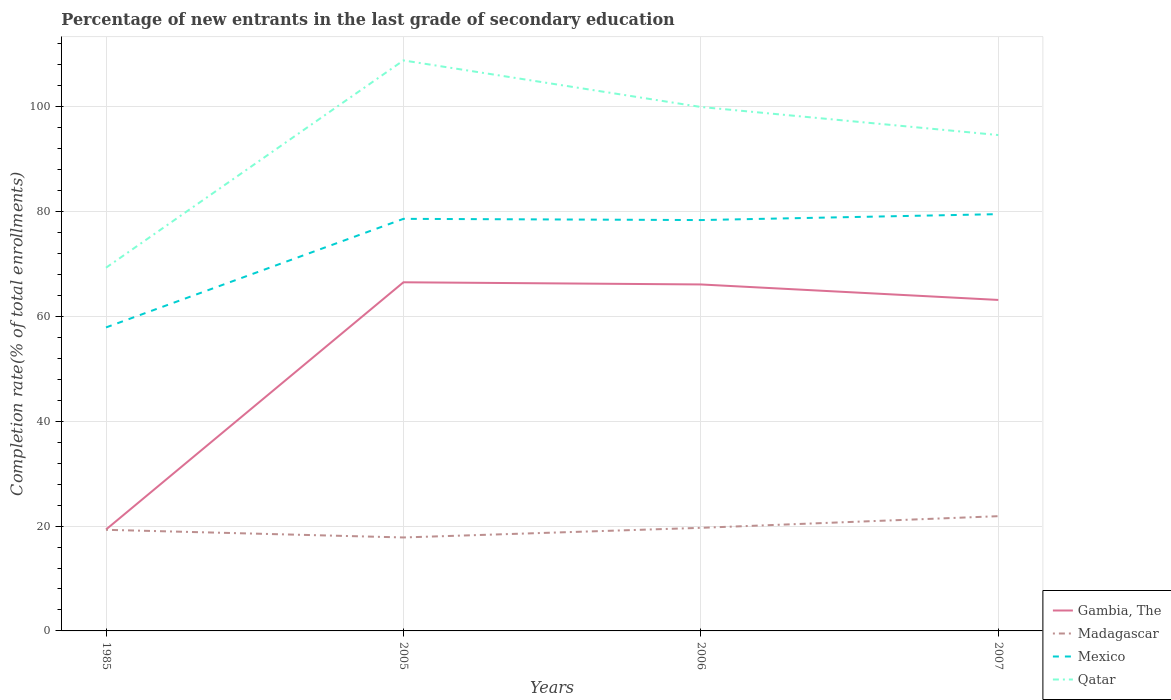Does the line corresponding to Qatar intersect with the line corresponding to Mexico?
Provide a short and direct response. No. Across all years, what is the maximum percentage of new entrants in Qatar?
Your answer should be compact. 69.3. What is the total percentage of new entrants in Mexico in the graph?
Ensure brevity in your answer.  -21.62. What is the difference between the highest and the second highest percentage of new entrants in Madagascar?
Your answer should be compact. 4.06. Is the percentage of new entrants in Mexico strictly greater than the percentage of new entrants in Gambia, The over the years?
Provide a short and direct response. No. How many lines are there?
Offer a terse response. 4. What is the difference between two consecutive major ticks on the Y-axis?
Make the answer very short. 20. Does the graph contain grids?
Give a very brief answer. Yes. Where does the legend appear in the graph?
Offer a terse response. Bottom right. How are the legend labels stacked?
Give a very brief answer. Vertical. What is the title of the graph?
Your response must be concise. Percentage of new entrants in the last grade of secondary education. Does "Arab World" appear as one of the legend labels in the graph?
Make the answer very short. No. What is the label or title of the Y-axis?
Ensure brevity in your answer.  Completion rate(% of total enrollments). What is the Completion rate(% of total enrollments) in Gambia, The in 1985?
Provide a succinct answer. 19.35. What is the Completion rate(% of total enrollments) in Madagascar in 1985?
Provide a succinct answer. 19.3. What is the Completion rate(% of total enrollments) in Mexico in 1985?
Your answer should be compact. 57.91. What is the Completion rate(% of total enrollments) in Qatar in 1985?
Your answer should be very brief. 69.3. What is the Completion rate(% of total enrollments) of Gambia, The in 2005?
Provide a short and direct response. 66.53. What is the Completion rate(% of total enrollments) in Madagascar in 2005?
Keep it short and to the point. 17.83. What is the Completion rate(% of total enrollments) of Mexico in 2005?
Your answer should be compact. 78.63. What is the Completion rate(% of total enrollments) in Qatar in 2005?
Offer a terse response. 108.86. What is the Completion rate(% of total enrollments) in Gambia, The in 2006?
Offer a very short reply. 66.11. What is the Completion rate(% of total enrollments) in Madagascar in 2006?
Give a very brief answer. 19.67. What is the Completion rate(% of total enrollments) of Mexico in 2006?
Your answer should be very brief. 78.4. What is the Completion rate(% of total enrollments) of Qatar in 2006?
Offer a very short reply. 99.98. What is the Completion rate(% of total enrollments) in Gambia, The in 2007?
Your answer should be very brief. 63.16. What is the Completion rate(% of total enrollments) in Madagascar in 2007?
Your answer should be compact. 21.89. What is the Completion rate(% of total enrollments) in Mexico in 2007?
Offer a terse response. 79.53. What is the Completion rate(% of total enrollments) in Qatar in 2007?
Offer a very short reply. 94.62. Across all years, what is the maximum Completion rate(% of total enrollments) of Gambia, The?
Your answer should be compact. 66.53. Across all years, what is the maximum Completion rate(% of total enrollments) in Madagascar?
Give a very brief answer. 21.89. Across all years, what is the maximum Completion rate(% of total enrollments) in Mexico?
Make the answer very short. 79.53. Across all years, what is the maximum Completion rate(% of total enrollments) of Qatar?
Give a very brief answer. 108.86. Across all years, what is the minimum Completion rate(% of total enrollments) in Gambia, The?
Your response must be concise. 19.35. Across all years, what is the minimum Completion rate(% of total enrollments) in Madagascar?
Make the answer very short. 17.83. Across all years, what is the minimum Completion rate(% of total enrollments) in Mexico?
Provide a short and direct response. 57.91. Across all years, what is the minimum Completion rate(% of total enrollments) in Qatar?
Your answer should be compact. 69.3. What is the total Completion rate(% of total enrollments) in Gambia, The in the graph?
Your response must be concise. 215.15. What is the total Completion rate(% of total enrollments) of Madagascar in the graph?
Give a very brief answer. 78.7. What is the total Completion rate(% of total enrollments) in Mexico in the graph?
Offer a very short reply. 294.47. What is the total Completion rate(% of total enrollments) in Qatar in the graph?
Give a very brief answer. 372.77. What is the difference between the Completion rate(% of total enrollments) of Gambia, The in 1985 and that in 2005?
Keep it short and to the point. -47.18. What is the difference between the Completion rate(% of total enrollments) of Madagascar in 1985 and that in 2005?
Keep it short and to the point. 1.46. What is the difference between the Completion rate(% of total enrollments) of Mexico in 1985 and that in 2005?
Your response must be concise. -20.72. What is the difference between the Completion rate(% of total enrollments) in Qatar in 1985 and that in 2005?
Your answer should be compact. -39.56. What is the difference between the Completion rate(% of total enrollments) of Gambia, The in 1985 and that in 2006?
Provide a short and direct response. -46.77. What is the difference between the Completion rate(% of total enrollments) of Madagascar in 1985 and that in 2006?
Offer a very short reply. -0.38. What is the difference between the Completion rate(% of total enrollments) in Mexico in 1985 and that in 2006?
Provide a succinct answer. -20.49. What is the difference between the Completion rate(% of total enrollments) in Qatar in 1985 and that in 2006?
Make the answer very short. -30.68. What is the difference between the Completion rate(% of total enrollments) of Gambia, The in 1985 and that in 2007?
Offer a very short reply. -43.81. What is the difference between the Completion rate(% of total enrollments) of Madagascar in 1985 and that in 2007?
Your response must be concise. -2.6. What is the difference between the Completion rate(% of total enrollments) in Mexico in 1985 and that in 2007?
Your response must be concise. -21.62. What is the difference between the Completion rate(% of total enrollments) of Qatar in 1985 and that in 2007?
Give a very brief answer. -25.32. What is the difference between the Completion rate(% of total enrollments) in Gambia, The in 2005 and that in 2006?
Offer a very short reply. 0.42. What is the difference between the Completion rate(% of total enrollments) in Madagascar in 2005 and that in 2006?
Offer a terse response. -1.84. What is the difference between the Completion rate(% of total enrollments) of Mexico in 2005 and that in 2006?
Your response must be concise. 0.23. What is the difference between the Completion rate(% of total enrollments) in Qatar in 2005 and that in 2006?
Provide a short and direct response. 8.88. What is the difference between the Completion rate(% of total enrollments) in Gambia, The in 2005 and that in 2007?
Offer a terse response. 3.37. What is the difference between the Completion rate(% of total enrollments) in Madagascar in 2005 and that in 2007?
Your answer should be very brief. -4.06. What is the difference between the Completion rate(% of total enrollments) in Mexico in 2005 and that in 2007?
Your response must be concise. -0.9. What is the difference between the Completion rate(% of total enrollments) of Qatar in 2005 and that in 2007?
Give a very brief answer. 14.24. What is the difference between the Completion rate(% of total enrollments) in Gambia, The in 2006 and that in 2007?
Make the answer very short. 2.96. What is the difference between the Completion rate(% of total enrollments) of Madagascar in 2006 and that in 2007?
Ensure brevity in your answer.  -2.22. What is the difference between the Completion rate(% of total enrollments) of Mexico in 2006 and that in 2007?
Make the answer very short. -1.13. What is the difference between the Completion rate(% of total enrollments) in Qatar in 2006 and that in 2007?
Provide a succinct answer. 5.36. What is the difference between the Completion rate(% of total enrollments) of Gambia, The in 1985 and the Completion rate(% of total enrollments) of Madagascar in 2005?
Give a very brief answer. 1.51. What is the difference between the Completion rate(% of total enrollments) in Gambia, The in 1985 and the Completion rate(% of total enrollments) in Mexico in 2005?
Provide a short and direct response. -59.29. What is the difference between the Completion rate(% of total enrollments) in Gambia, The in 1985 and the Completion rate(% of total enrollments) in Qatar in 2005?
Provide a succinct answer. -89.51. What is the difference between the Completion rate(% of total enrollments) of Madagascar in 1985 and the Completion rate(% of total enrollments) of Mexico in 2005?
Keep it short and to the point. -59.34. What is the difference between the Completion rate(% of total enrollments) of Madagascar in 1985 and the Completion rate(% of total enrollments) of Qatar in 2005?
Provide a short and direct response. -89.56. What is the difference between the Completion rate(% of total enrollments) in Mexico in 1985 and the Completion rate(% of total enrollments) in Qatar in 2005?
Offer a terse response. -50.95. What is the difference between the Completion rate(% of total enrollments) of Gambia, The in 1985 and the Completion rate(% of total enrollments) of Madagascar in 2006?
Provide a succinct answer. -0.32. What is the difference between the Completion rate(% of total enrollments) of Gambia, The in 1985 and the Completion rate(% of total enrollments) of Mexico in 2006?
Give a very brief answer. -59.05. What is the difference between the Completion rate(% of total enrollments) of Gambia, The in 1985 and the Completion rate(% of total enrollments) of Qatar in 2006?
Offer a terse response. -80.63. What is the difference between the Completion rate(% of total enrollments) of Madagascar in 1985 and the Completion rate(% of total enrollments) of Mexico in 2006?
Keep it short and to the point. -59.1. What is the difference between the Completion rate(% of total enrollments) of Madagascar in 1985 and the Completion rate(% of total enrollments) of Qatar in 2006?
Your answer should be very brief. -80.68. What is the difference between the Completion rate(% of total enrollments) in Mexico in 1985 and the Completion rate(% of total enrollments) in Qatar in 2006?
Your response must be concise. -42.07. What is the difference between the Completion rate(% of total enrollments) in Gambia, The in 1985 and the Completion rate(% of total enrollments) in Madagascar in 2007?
Keep it short and to the point. -2.55. What is the difference between the Completion rate(% of total enrollments) of Gambia, The in 1985 and the Completion rate(% of total enrollments) of Mexico in 2007?
Ensure brevity in your answer.  -60.18. What is the difference between the Completion rate(% of total enrollments) of Gambia, The in 1985 and the Completion rate(% of total enrollments) of Qatar in 2007?
Provide a succinct answer. -75.28. What is the difference between the Completion rate(% of total enrollments) in Madagascar in 1985 and the Completion rate(% of total enrollments) in Mexico in 2007?
Your answer should be very brief. -60.23. What is the difference between the Completion rate(% of total enrollments) of Madagascar in 1985 and the Completion rate(% of total enrollments) of Qatar in 2007?
Provide a short and direct response. -75.33. What is the difference between the Completion rate(% of total enrollments) in Mexico in 1985 and the Completion rate(% of total enrollments) in Qatar in 2007?
Give a very brief answer. -36.71. What is the difference between the Completion rate(% of total enrollments) in Gambia, The in 2005 and the Completion rate(% of total enrollments) in Madagascar in 2006?
Make the answer very short. 46.86. What is the difference between the Completion rate(% of total enrollments) in Gambia, The in 2005 and the Completion rate(% of total enrollments) in Mexico in 2006?
Your answer should be very brief. -11.87. What is the difference between the Completion rate(% of total enrollments) in Gambia, The in 2005 and the Completion rate(% of total enrollments) in Qatar in 2006?
Offer a very short reply. -33.45. What is the difference between the Completion rate(% of total enrollments) of Madagascar in 2005 and the Completion rate(% of total enrollments) of Mexico in 2006?
Keep it short and to the point. -60.57. What is the difference between the Completion rate(% of total enrollments) of Madagascar in 2005 and the Completion rate(% of total enrollments) of Qatar in 2006?
Provide a succinct answer. -82.14. What is the difference between the Completion rate(% of total enrollments) in Mexico in 2005 and the Completion rate(% of total enrollments) in Qatar in 2006?
Provide a succinct answer. -21.35. What is the difference between the Completion rate(% of total enrollments) of Gambia, The in 2005 and the Completion rate(% of total enrollments) of Madagascar in 2007?
Your answer should be very brief. 44.63. What is the difference between the Completion rate(% of total enrollments) in Gambia, The in 2005 and the Completion rate(% of total enrollments) in Mexico in 2007?
Give a very brief answer. -13. What is the difference between the Completion rate(% of total enrollments) of Gambia, The in 2005 and the Completion rate(% of total enrollments) of Qatar in 2007?
Give a very brief answer. -28.09. What is the difference between the Completion rate(% of total enrollments) in Madagascar in 2005 and the Completion rate(% of total enrollments) in Mexico in 2007?
Offer a terse response. -61.7. What is the difference between the Completion rate(% of total enrollments) in Madagascar in 2005 and the Completion rate(% of total enrollments) in Qatar in 2007?
Provide a succinct answer. -76.79. What is the difference between the Completion rate(% of total enrollments) of Mexico in 2005 and the Completion rate(% of total enrollments) of Qatar in 2007?
Offer a terse response. -15.99. What is the difference between the Completion rate(% of total enrollments) of Gambia, The in 2006 and the Completion rate(% of total enrollments) of Madagascar in 2007?
Offer a terse response. 44.22. What is the difference between the Completion rate(% of total enrollments) of Gambia, The in 2006 and the Completion rate(% of total enrollments) of Mexico in 2007?
Make the answer very short. -13.42. What is the difference between the Completion rate(% of total enrollments) of Gambia, The in 2006 and the Completion rate(% of total enrollments) of Qatar in 2007?
Your answer should be very brief. -28.51. What is the difference between the Completion rate(% of total enrollments) in Madagascar in 2006 and the Completion rate(% of total enrollments) in Mexico in 2007?
Make the answer very short. -59.86. What is the difference between the Completion rate(% of total enrollments) of Madagascar in 2006 and the Completion rate(% of total enrollments) of Qatar in 2007?
Make the answer very short. -74.95. What is the difference between the Completion rate(% of total enrollments) of Mexico in 2006 and the Completion rate(% of total enrollments) of Qatar in 2007?
Your answer should be compact. -16.22. What is the average Completion rate(% of total enrollments) in Gambia, The per year?
Offer a very short reply. 53.79. What is the average Completion rate(% of total enrollments) in Madagascar per year?
Make the answer very short. 19.67. What is the average Completion rate(% of total enrollments) of Mexico per year?
Keep it short and to the point. 73.62. What is the average Completion rate(% of total enrollments) of Qatar per year?
Ensure brevity in your answer.  93.19. In the year 1985, what is the difference between the Completion rate(% of total enrollments) of Gambia, The and Completion rate(% of total enrollments) of Madagascar?
Make the answer very short. 0.05. In the year 1985, what is the difference between the Completion rate(% of total enrollments) in Gambia, The and Completion rate(% of total enrollments) in Mexico?
Offer a terse response. -38.56. In the year 1985, what is the difference between the Completion rate(% of total enrollments) in Gambia, The and Completion rate(% of total enrollments) in Qatar?
Make the answer very short. -49.96. In the year 1985, what is the difference between the Completion rate(% of total enrollments) in Madagascar and Completion rate(% of total enrollments) in Mexico?
Offer a terse response. -38.61. In the year 1985, what is the difference between the Completion rate(% of total enrollments) in Madagascar and Completion rate(% of total enrollments) in Qatar?
Provide a short and direct response. -50.01. In the year 1985, what is the difference between the Completion rate(% of total enrollments) in Mexico and Completion rate(% of total enrollments) in Qatar?
Your answer should be compact. -11.39. In the year 2005, what is the difference between the Completion rate(% of total enrollments) of Gambia, The and Completion rate(% of total enrollments) of Madagascar?
Your response must be concise. 48.69. In the year 2005, what is the difference between the Completion rate(% of total enrollments) of Gambia, The and Completion rate(% of total enrollments) of Mexico?
Your answer should be very brief. -12.11. In the year 2005, what is the difference between the Completion rate(% of total enrollments) of Gambia, The and Completion rate(% of total enrollments) of Qatar?
Provide a succinct answer. -42.33. In the year 2005, what is the difference between the Completion rate(% of total enrollments) of Madagascar and Completion rate(% of total enrollments) of Mexico?
Offer a very short reply. -60.8. In the year 2005, what is the difference between the Completion rate(% of total enrollments) of Madagascar and Completion rate(% of total enrollments) of Qatar?
Offer a terse response. -91.03. In the year 2005, what is the difference between the Completion rate(% of total enrollments) in Mexico and Completion rate(% of total enrollments) in Qatar?
Keep it short and to the point. -30.23. In the year 2006, what is the difference between the Completion rate(% of total enrollments) of Gambia, The and Completion rate(% of total enrollments) of Madagascar?
Your answer should be compact. 46.44. In the year 2006, what is the difference between the Completion rate(% of total enrollments) in Gambia, The and Completion rate(% of total enrollments) in Mexico?
Keep it short and to the point. -12.29. In the year 2006, what is the difference between the Completion rate(% of total enrollments) in Gambia, The and Completion rate(% of total enrollments) in Qatar?
Keep it short and to the point. -33.87. In the year 2006, what is the difference between the Completion rate(% of total enrollments) of Madagascar and Completion rate(% of total enrollments) of Mexico?
Your answer should be very brief. -58.73. In the year 2006, what is the difference between the Completion rate(% of total enrollments) of Madagascar and Completion rate(% of total enrollments) of Qatar?
Make the answer very short. -80.31. In the year 2006, what is the difference between the Completion rate(% of total enrollments) of Mexico and Completion rate(% of total enrollments) of Qatar?
Give a very brief answer. -21.58. In the year 2007, what is the difference between the Completion rate(% of total enrollments) in Gambia, The and Completion rate(% of total enrollments) in Madagascar?
Your answer should be very brief. 41.26. In the year 2007, what is the difference between the Completion rate(% of total enrollments) in Gambia, The and Completion rate(% of total enrollments) in Mexico?
Your answer should be compact. -16.37. In the year 2007, what is the difference between the Completion rate(% of total enrollments) of Gambia, The and Completion rate(% of total enrollments) of Qatar?
Provide a succinct answer. -31.47. In the year 2007, what is the difference between the Completion rate(% of total enrollments) in Madagascar and Completion rate(% of total enrollments) in Mexico?
Offer a very short reply. -57.63. In the year 2007, what is the difference between the Completion rate(% of total enrollments) of Madagascar and Completion rate(% of total enrollments) of Qatar?
Keep it short and to the point. -72.73. In the year 2007, what is the difference between the Completion rate(% of total enrollments) of Mexico and Completion rate(% of total enrollments) of Qatar?
Give a very brief answer. -15.09. What is the ratio of the Completion rate(% of total enrollments) of Gambia, The in 1985 to that in 2005?
Make the answer very short. 0.29. What is the ratio of the Completion rate(% of total enrollments) in Madagascar in 1985 to that in 2005?
Your answer should be very brief. 1.08. What is the ratio of the Completion rate(% of total enrollments) of Mexico in 1985 to that in 2005?
Ensure brevity in your answer.  0.74. What is the ratio of the Completion rate(% of total enrollments) of Qatar in 1985 to that in 2005?
Your answer should be very brief. 0.64. What is the ratio of the Completion rate(% of total enrollments) of Gambia, The in 1985 to that in 2006?
Offer a terse response. 0.29. What is the ratio of the Completion rate(% of total enrollments) in Madagascar in 1985 to that in 2006?
Provide a succinct answer. 0.98. What is the ratio of the Completion rate(% of total enrollments) in Mexico in 1985 to that in 2006?
Make the answer very short. 0.74. What is the ratio of the Completion rate(% of total enrollments) in Qatar in 1985 to that in 2006?
Offer a terse response. 0.69. What is the ratio of the Completion rate(% of total enrollments) of Gambia, The in 1985 to that in 2007?
Your answer should be compact. 0.31. What is the ratio of the Completion rate(% of total enrollments) in Madagascar in 1985 to that in 2007?
Offer a very short reply. 0.88. What is the ratio of the Completion rate(% of total enrollments) of Mexico in 1985 to that in 2007?
Ensure brevity in your answer.  0.73. What is the ratio of the Completion rate(% of total enrollments) in Qatar in 1985 to that in 2007?
Ensure brevity in your answer.  0.73. What is the ratio of the Completion rate(% of total enrollments) in Gambia, The in 2005 to that in 2006?
Offer a very short reply. 1.01. What is the ratio of the Completion rate(% of total enrollments) of Madagascar in 2005 to that in 2006?
Ensure brevity in your answer.  0.91. What is the ratio of the Completion rate(% of total enrollments) in Mexico in 2005 to that in 2006?
Provide a short and direct response. 1. What is the ratio of the Completion rate(% of total enrollments) in Qatar in 2005 to that in 2006?
Your response must be concise. 1.09. What is the ratio of the Completion rate(% of total enrollments) of Gambia, The in 2005 to that in 2007?
Make the answer very short. 1.05. What is the ratio of the Completion rate(% of total enrollments) of Madagascar in 2005 to that in 2007?
Offer a very short reply. 0.81. What is the ratio of the Completion rate(% of total enrollments) in Mexico in 2005 to that in 2007?
Your answer should be compact. 0.99. What is the ratio of the Completion rate(% of total enrollments) of Qatar in 2005 to that in 2007?
Your response must be concise. 1.15. What is the ratio of the Completion rate(% of total enrollments) of Gambia, The in 2006 to that in 2007?
Make the answer very short. 1.05. What is the ratio of the Completion rate(% of total enrollments) of Madagascar in 2006 to that in 2007?
Your response must be concise. 0.9. What is the ratio of the Completion rate(% of total enrollments) in Mexico in 2006 to that in 2007?
Your response must be concise. 0.99. What is the ratio of the Completion rate(% of total enrollments) of Qatar in 2006 to that in 2007?
Your answer should be compact. 1.06. What is the difference between the highest and the second highest Completion rate(% of total enrollments) of Gambia, The?
Offer a terse response. 0.42. What is the difference between the highest and the second highest Completion rate(% of total enrollments) of Madagascar?
Keep it short and to the point. 2.22. What is the difference between the highest and the second highest Completion rate(% of total enrollments) of Mexico?
Your answer should be very brief. 0.9. What is the difference between the highest and the second highest Completion rate(% of total enrollments) of Qatar?
Offer a terse response. 8.88. What is the difference between the highest and the lowest Completion rate(% of total enrollments) in Gambia, The?
Provide a short and direct response. 47.18. What is the difference between the highest and the lowest Completion rate(% of total enrollments) in Madagascar?
Provide a succinct answer. 4.06. What is the difference between the highest and the lowest Completion rate(% of total enrollments) in Mexico?
Your answer should be compact. 21.62. What is the difference between the highest and the lowest Completion rate(% of total enrollments) of Qatar?
Give a very brief answer. 39.56. 